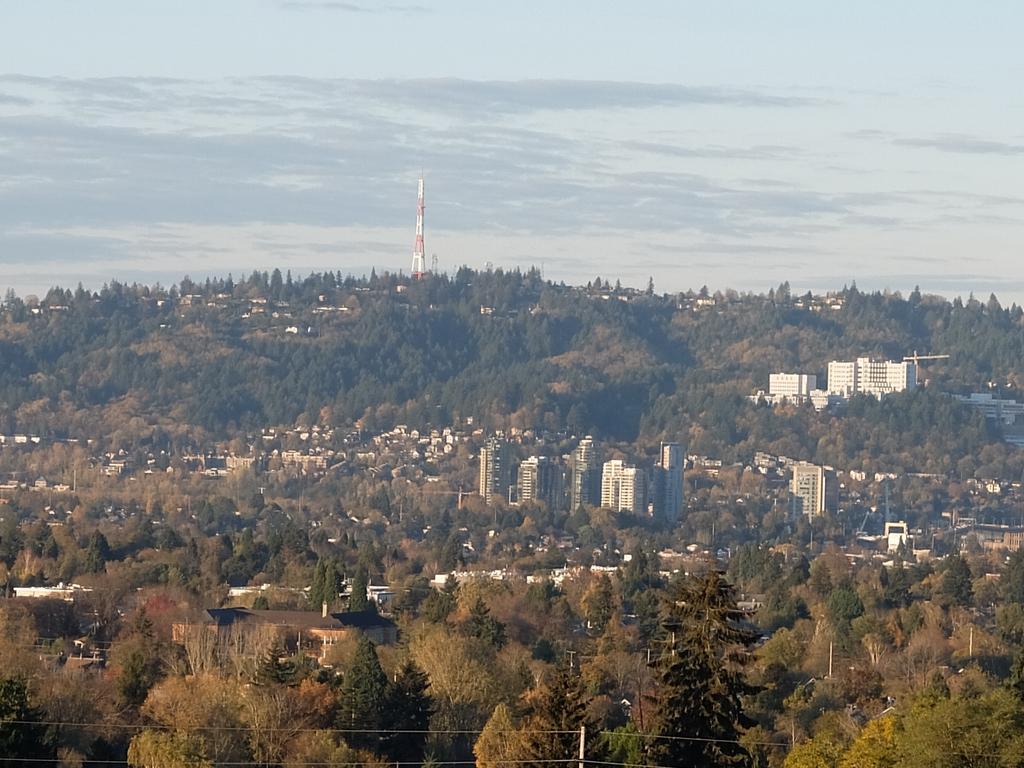Can you describe this image briefly? This picture is taken from outside of the city. In this image, we can see some trees, buildings, houses, plants, pole. At the top, we can see a sky which is a bit cloudy, at the bottom, we can see some wires and a pole. 